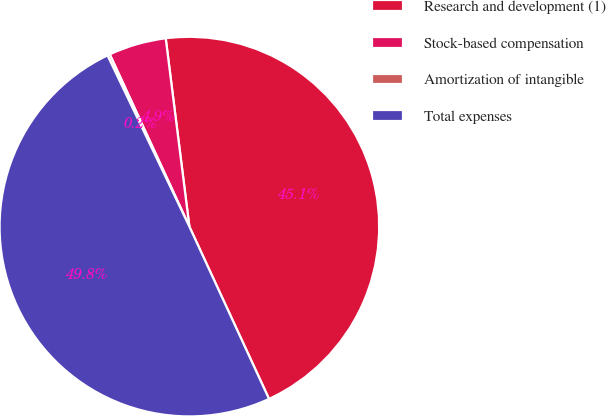Convert chart to OTSL. <chart><loc_0><loc_0><loc_500><loc_500><pie_chart><fcel>Research and development (1)<fcel>Stock-based compensation<fcel>Amortization of intangible<fcel>Total expenses<nl><fcel>45.1%<fcel>4.9%<fcel>0.21%<fcel>49.79%<nl></chart> 